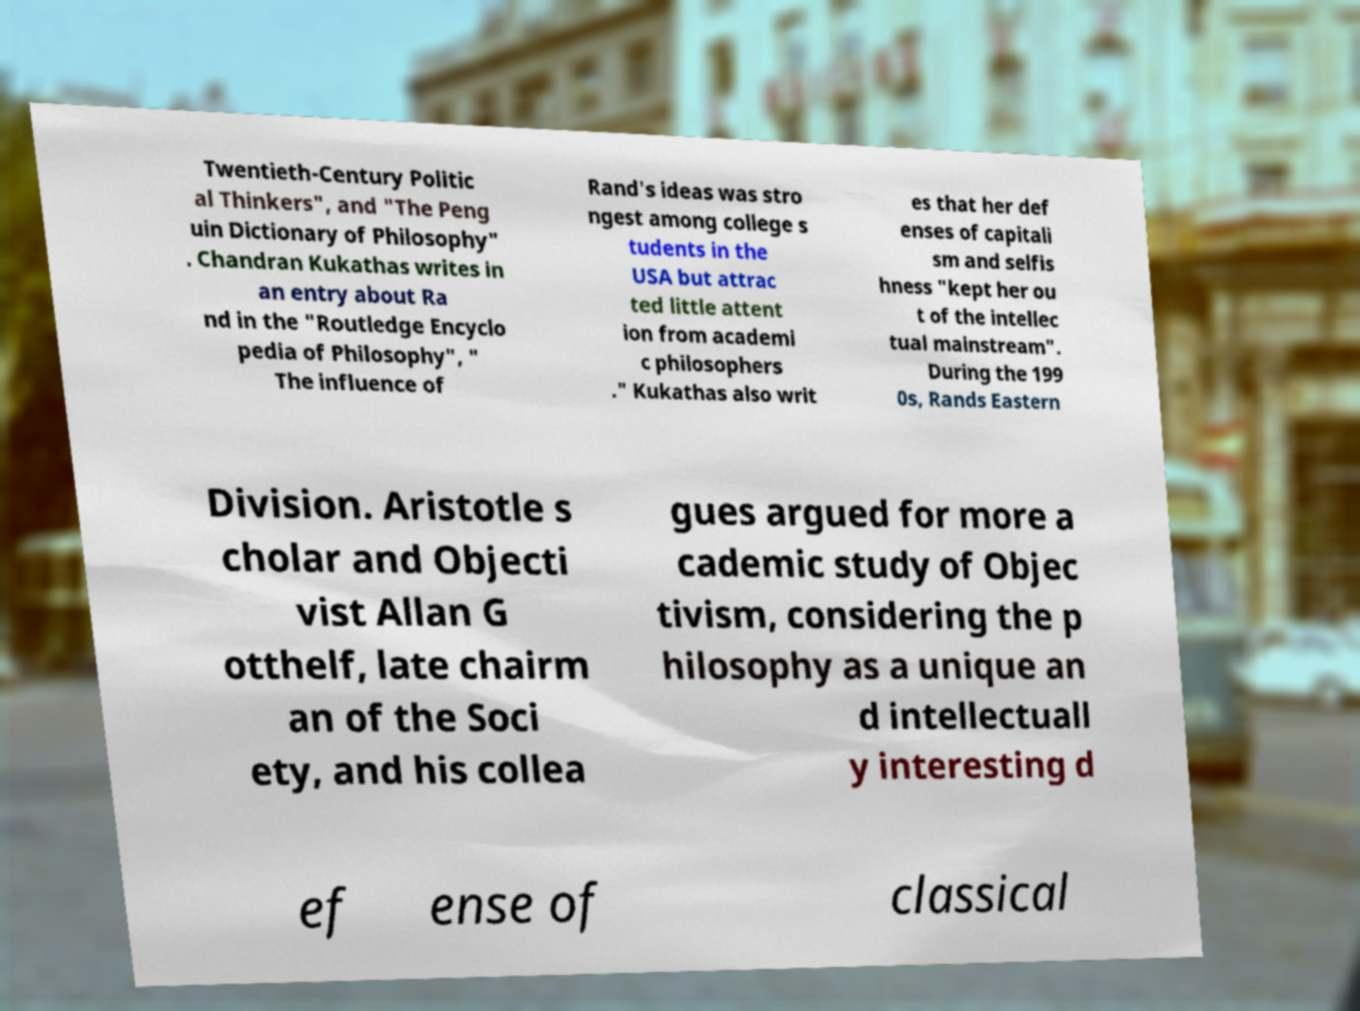I need the written content from this picture converted into text. Can you do that? Twentieth-Century Politic al Thinkers", and "The Peng uin Dictionary of Philosophy" . Chandran Kukathas writes in an entry about Ra nd in the "Routledge Encyclo pedia of Philosophy", " The influence of Rand's ideas was stro ngest among college s tudents in the USA but attrac ted little attent ion from academi c philosophers ." Kukathas also writ es that her def enses of capitali sm and selfis hness "kept her ou t of the intellec tual mainstream". During the 199 0s, Rands Eastern Division. Aristotle s cholar and Objecti vist Allan G otthelf, late chairm an of the Soci ety, and his collea gues argued for more a cademic study of Objec tivism, considering the p hilosophy as a unique an d intellectuall y interesting d ef ense of classical 